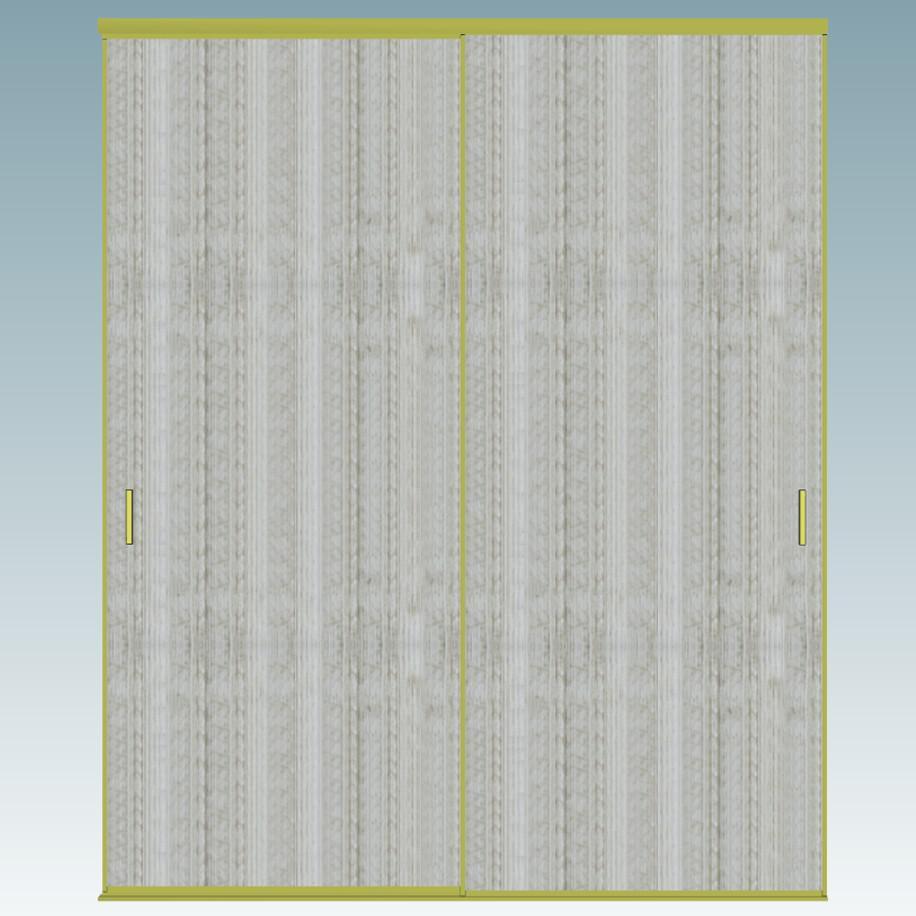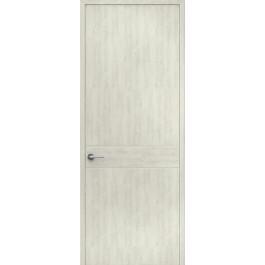The first image is the image on the left, the second image is the image on the right. Considering the images on both sides, is "The closet in the image on the left is partially open." valid? Answer yes or no. No. 